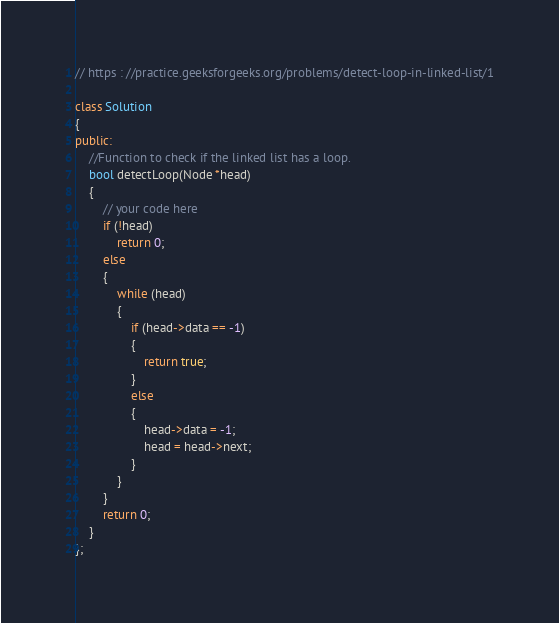Convert code to text. <code><loc_0><loc_0><loc_500><loc_500><_C++_>// https : //practice.geeksforgeeks.org/problems/detect-loop-in-linked-list/1

class Solution
{
public:
    //Function to check if the linked list has a loop.
    bool detectLoop(Node *head)
    {
        // your code here
        if (!head)
            return 0;
        else
        {
            while (head)
            {
                if (head->data == -1)
                {
                    return true;
                }
                else
                {
                    head->data = -1;
                    head = head->next;
                }
            }
        }
        return 0;
    }
};</code> 